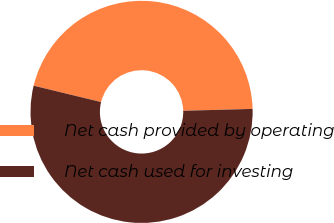<chart> <loc_0><loc_0><loc_500><loc_500><pie_chart><fcel>Net cash provided by operating<fcel>Net cash used for investing<nl><fcel>45.78%<fcel>54.22%<nl></chart> 